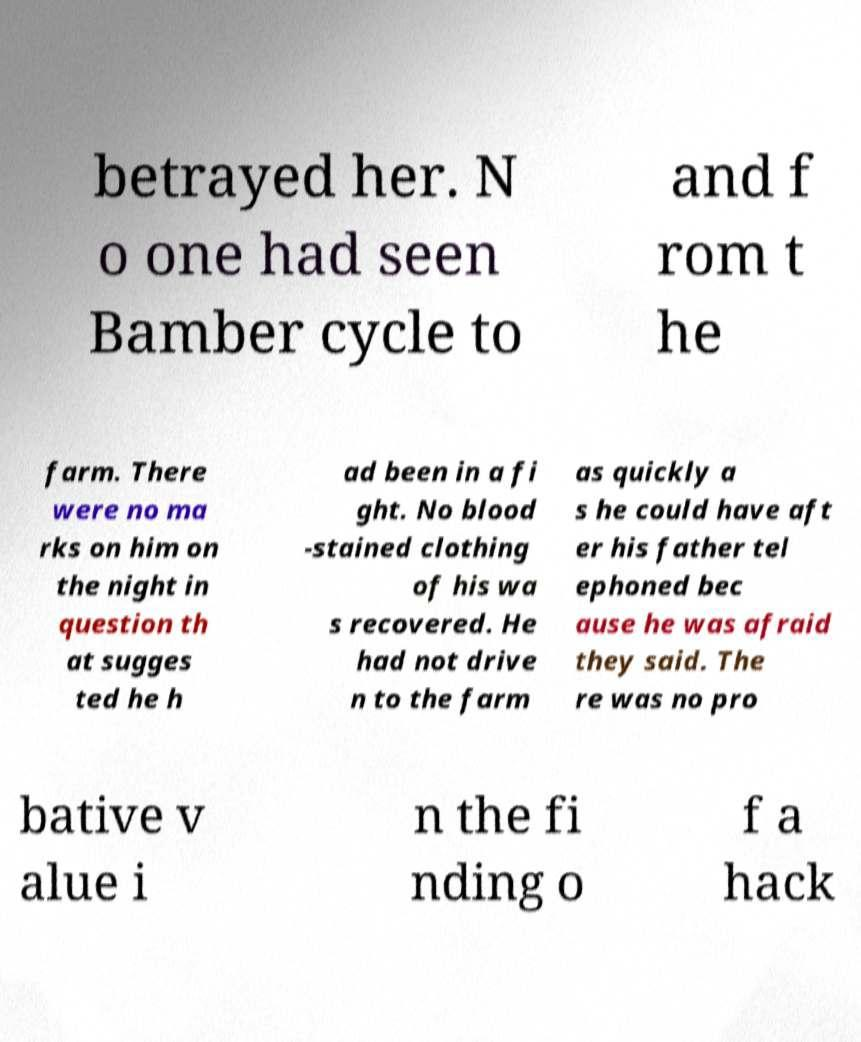I need the written content from this picture converted into text. Can you do that? betrayed her. N o one had seen Bamber cycle to and f rom t he farm. There were no ma rks on him on the night in question th at sugges ted he h ad been in a fi ght. No blood -stained clothing of his wa s recovered. He had not drive n to the farm as quickly a s he could have aft er his father tel ephoned bec ause he was afraid they said. The re was no pro bative v alue i n the fi nding o f a hack 